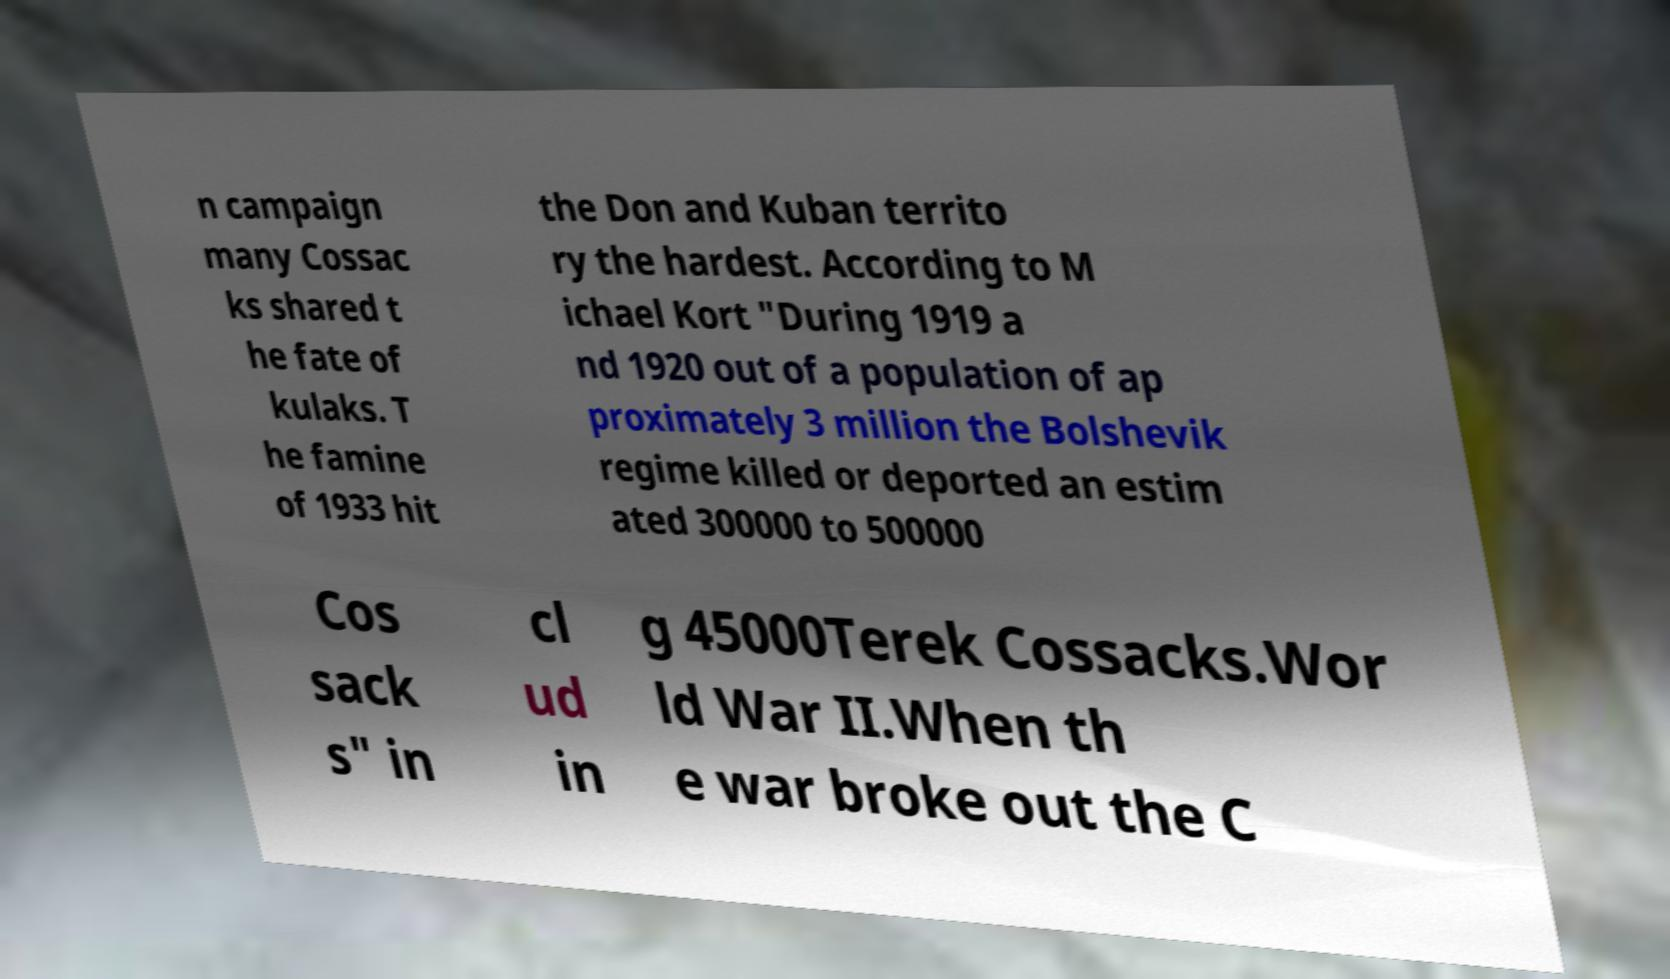What messages or text are displayed in this image? I need them in a readable, typed format. n campaign many Cossac ks shared t he fate of kulaks. T he famine of 1933 hit the Don and Kuban territo ry the hardest. According to M ichael Kort "During 1919 a nd 1920 out of a population of ap proximately 3 million the Bolshevik regime killed or deported an estim ated 300000 to 500000 Cos sack s" in cl ud in g 45000Terek Cossacks.Wor ld War II.When th e war broke out the C 